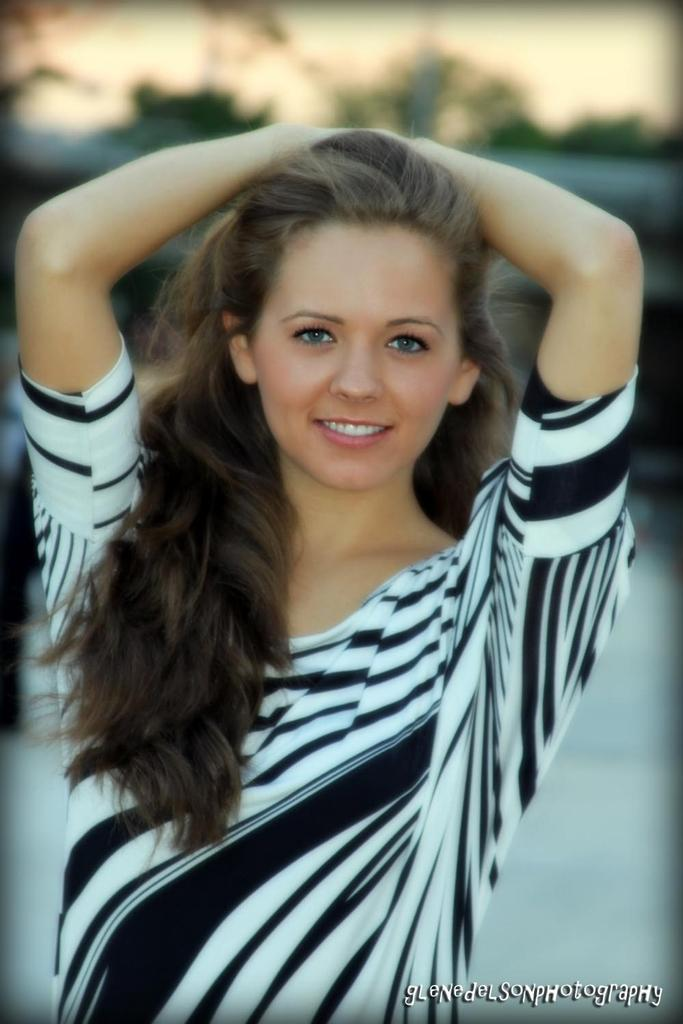Who is the main subject in the picture? There is a woman in the picture. What is the woman doing in the image? The woman is smiling. What is the woman wearing in the image? The woman is wearing a black and white top. What is the woman doing with her hands in the image? The woman has her hands on her head. How many worms can be seen crawling on the woman's head in the image? There are no worms present in the image, and therefore no worms can be seen crawling on the woman's head. 